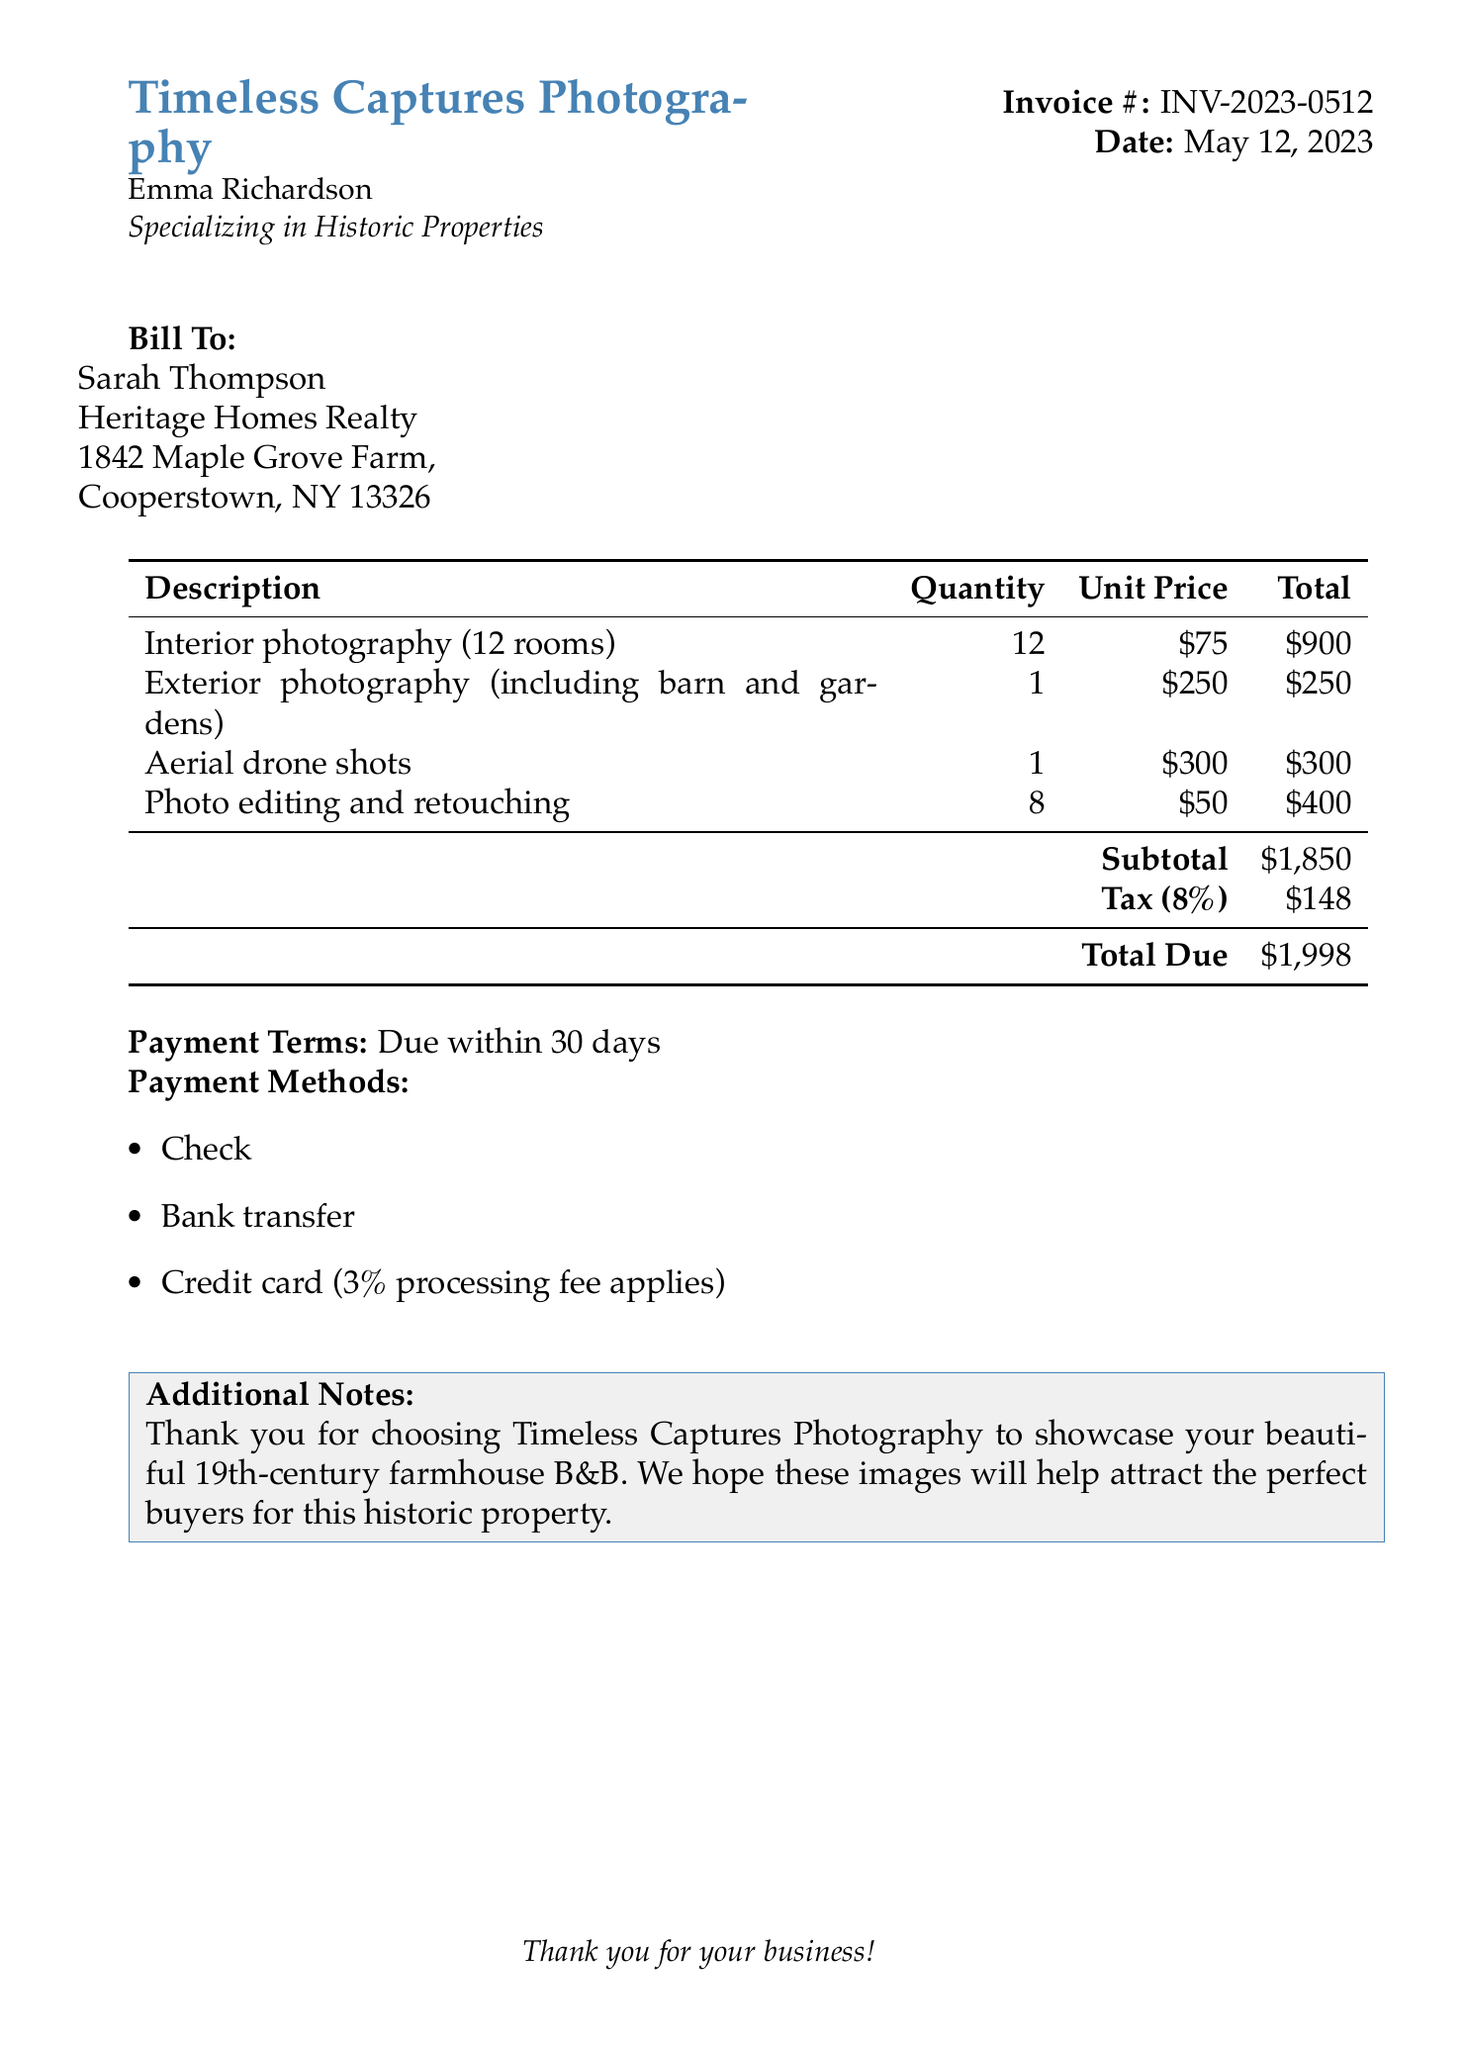What is the invoice number? The invoice number is clearly stated in the document as INV-2023-0512.
Answer: INV-2023-0512 Who is the bill to? The document specifies that the billing recipient is Sarah Thompson.
Answer: Sarah Thompson What is the subtotal amount? The subtotal is calculated as the sum of all service charges before tax, which is listed as $1,850.
Answer: $1,850 How many rooms were photographed interiorly? The document indicates that interior photography was done for 12 rooms.
Answer: 12 What is the total due? The document states the total due after tax is $1,998.
Answer: $1,998 What is the tax rate applied? The tax rate mentioned in the document is 8%.
Answer: 8% What is the payment term? The payment terms specified state payment is due within 30 days.
Answer: Due within 30 days What services included aerial shots? Aerial drone shots are clearly listed as one of the services provided in the invoice.
Answer: Aerial drone shots How much is charged for photo editing? The document details that photo editing and retouching costs $400 based on the quantity and unit price.
Answer: $400 